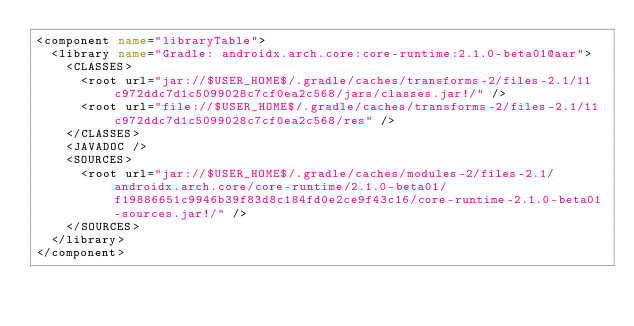<code> <loc_0><loc_0><loc_500><loc_500><_XML_><component name="libraryTable">
  <library name="Gradle: androidx.arch.core:core-runtime:2.1.0-beta01@aar">
    <CLASSES>
      <root url="jar://$USER_HOME$/.gradle/caches/transforms-2/files-2.1/11c972ddc7d1c5099028c7cf0ea2c568/jars/classes.jar!/" />
      <root url="file://$USER_HOME$/.gradle/caches/transforms-2/files-2.1/11c972ddc7d1c5099028c7cf0ea2c568/res" />
    </CLASSES>
    <JAVADOC />
    <SOURCES>
      <root url="jar://$USER_HOME$/.gradle/caches/modules-2/files-2.1/androidx.arch.core/core-runtime/2.1.0-beta01/f19886651c9946b39f83d8c184fd0e2ce9f43c16/core-runtime-2.1.0-beta01-sources.jar!/" />
    </SOURCES>
  </library>
</component></code> 